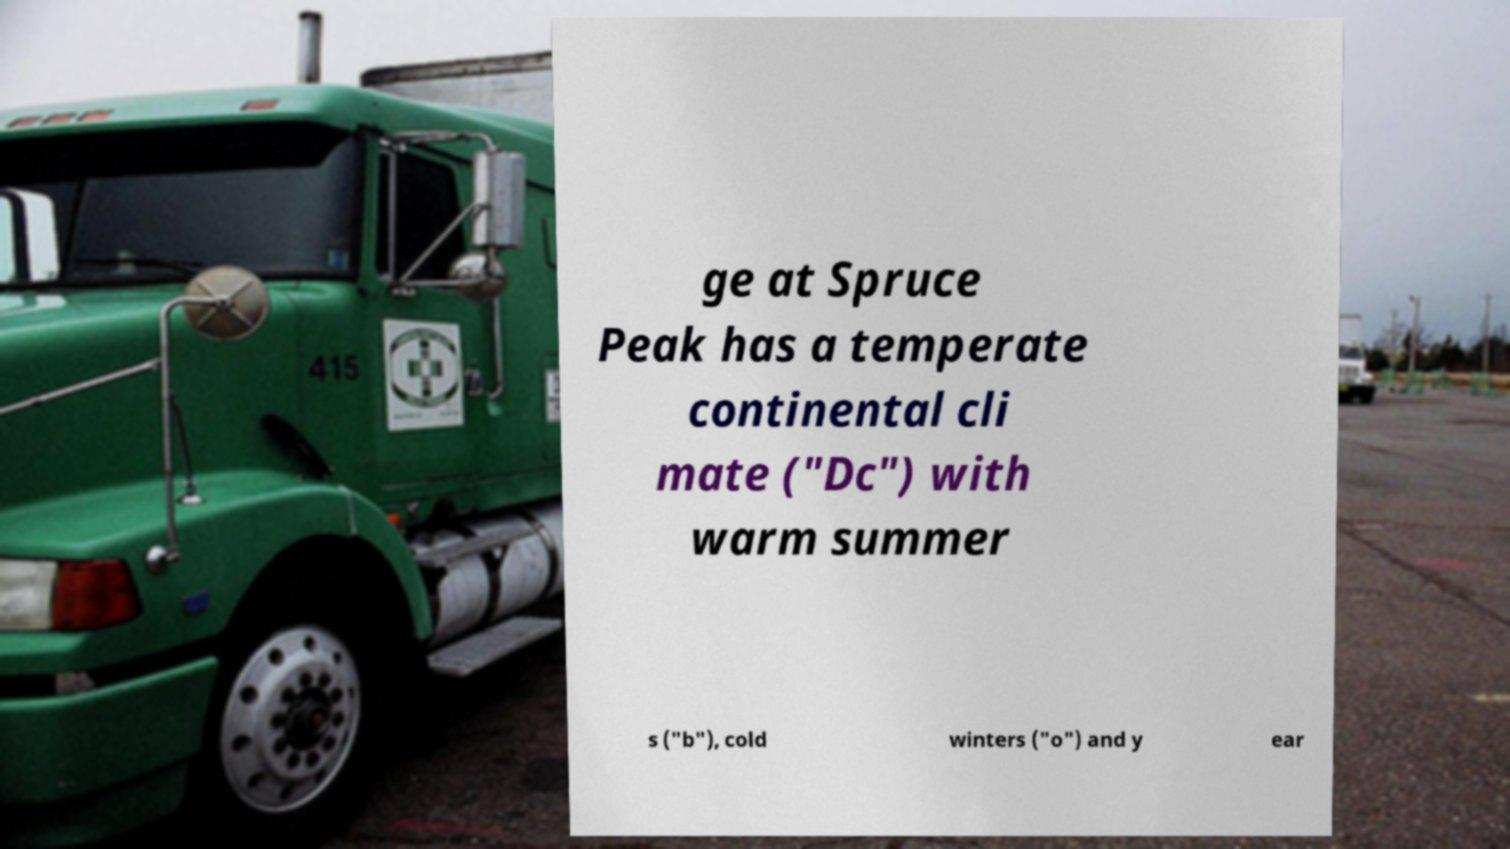Can you accurately transcribe the text from the provided image for me? ge at Spruce Peak has a temperate continental cli mate ("Dc") with warm summer s ("b"), cold winters ("o") and y ear 